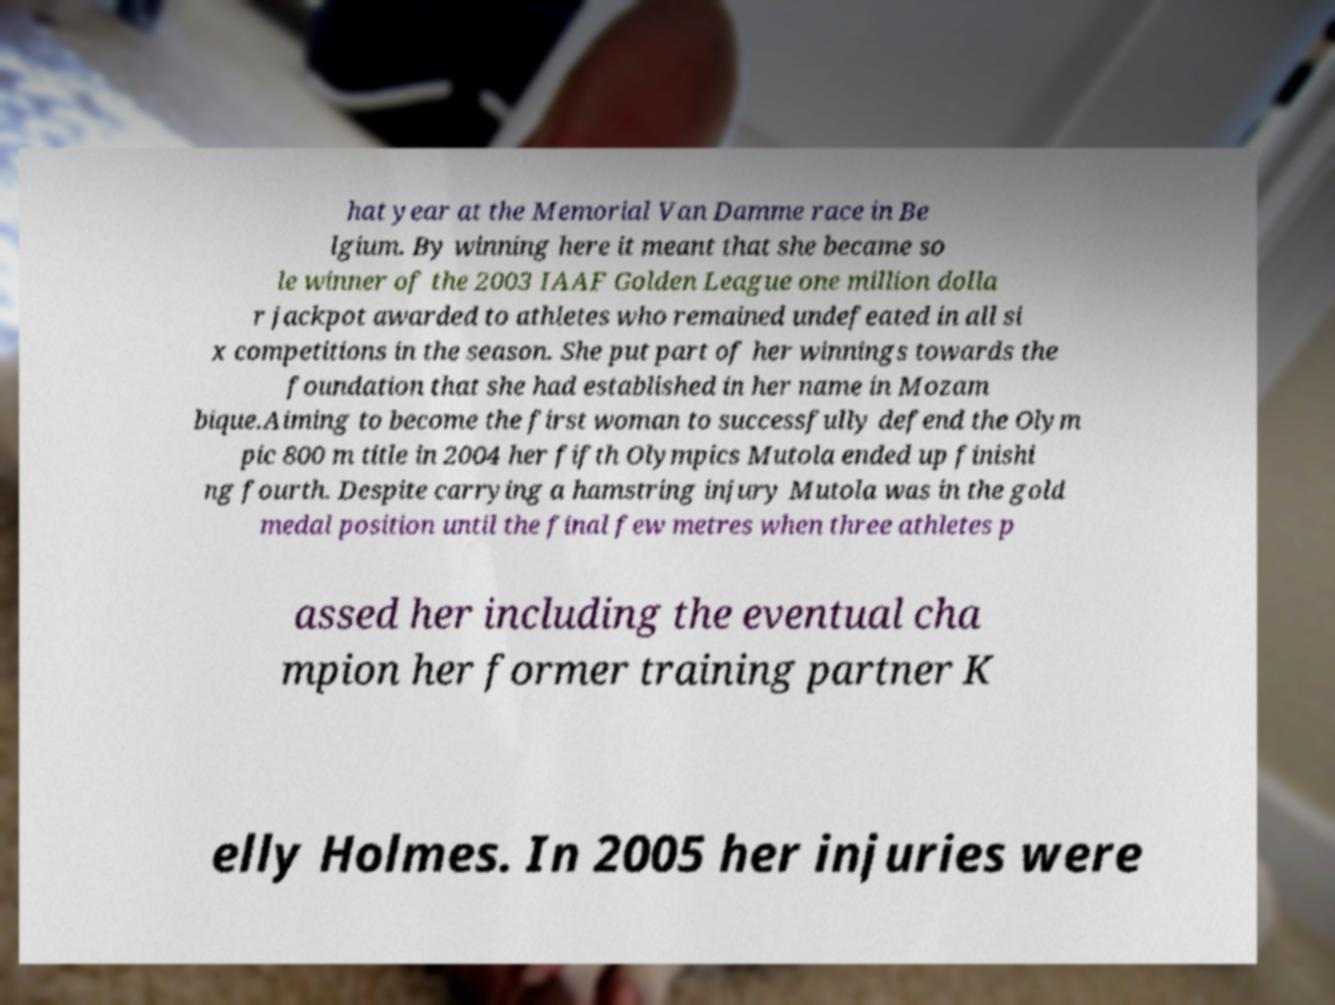Could you extract and type out the text from this image? hat year at the Memorial Van Damme race in Be lgium. By winning here it meant that she became so le winner of the 2003 IAAF Golden League one million dolla r jackpot awarded to athletes who remained undefeated in all si x competitions in the season. She put part of her winnings towards the foundation that she had established in her name in Mozam bique.Aiming to become the first woman to successfully defend the Olym pic 800 m title in 2004 her fifth Olympics Mutola ended up finishi ng fourth. Despite carrying a hamstring injury Mutola was in the gold medal position until the final few metres when three athletes p assed her including the eventual cha mpion her former training partner K elly Holmes. In 2005 her injuries were 